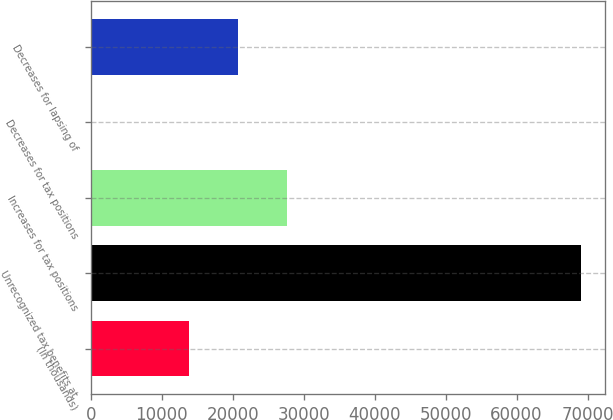Convert chart. <chart><loc_0><loc_0><loc_500><loc_500><bar_chart><fcel>(In thousands)<fcel>Unrecognized tax benefits at<fcel>Increases for tax positions<fcel>Decreases for tax positions<fcel>Decreases for lapsing of<nl><fcel>13809.2<fcel>69018<fcel>27611.4<fcel>7<fcel>20710.3<nl></chart> 